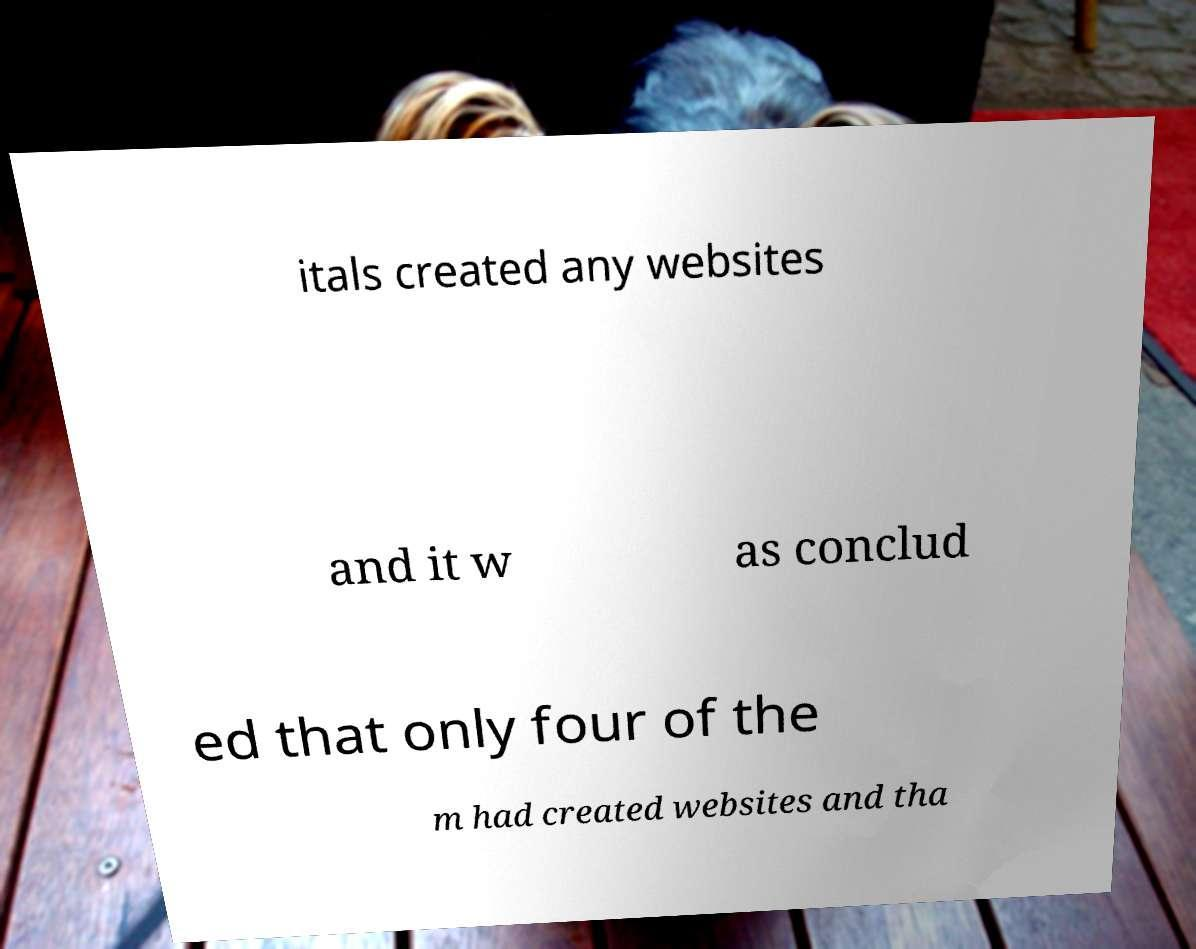Please read and relay the text visible in this image. What does it say? itals created any websites and it w as conclud ed that only four of the m had created websites and tha 